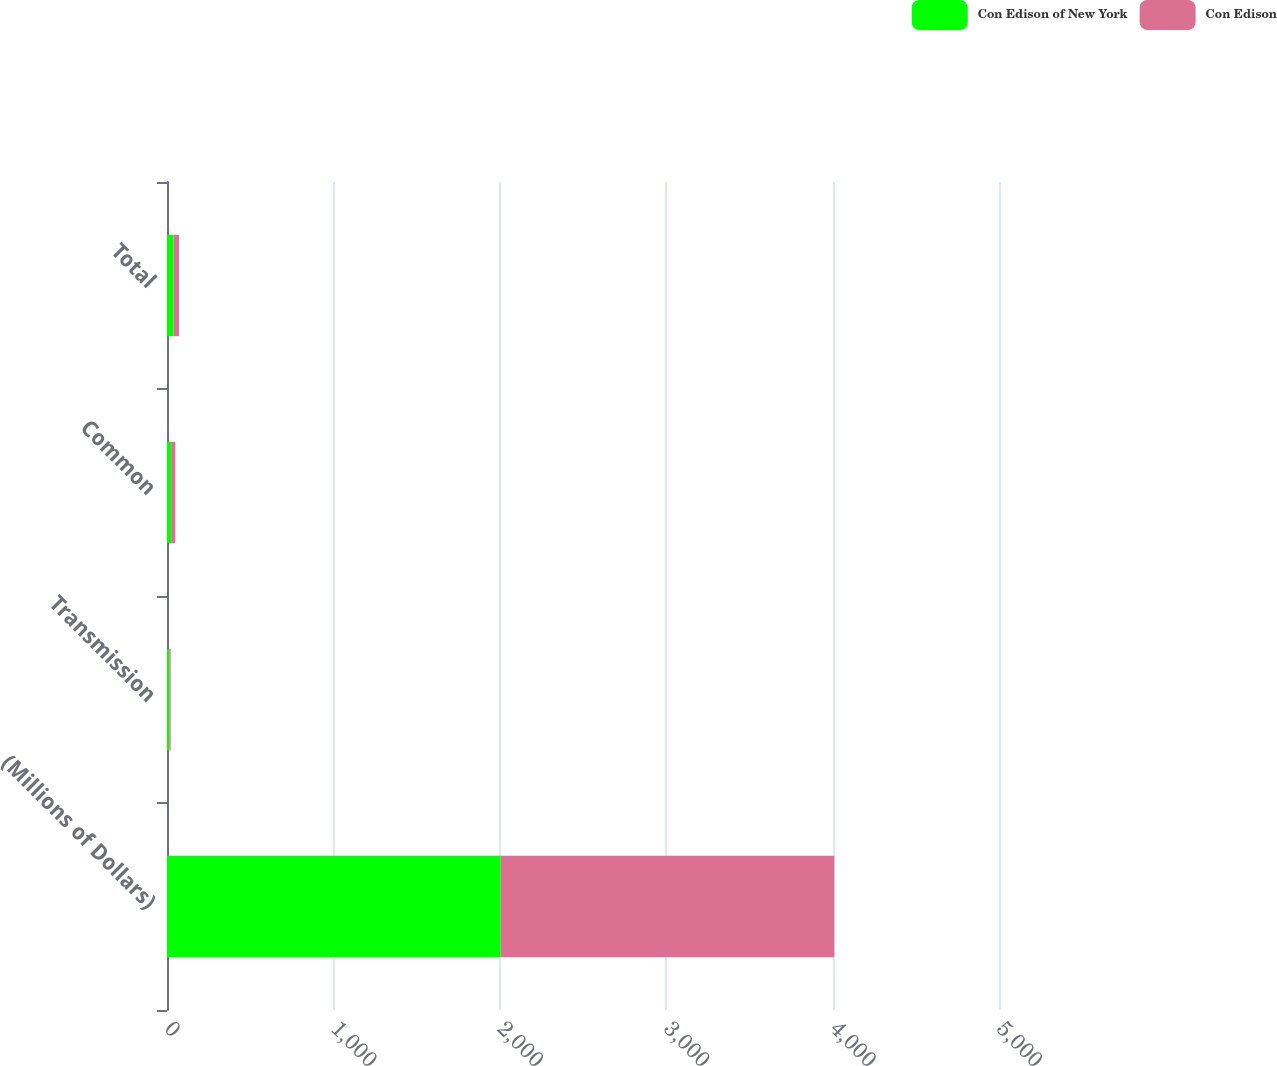Convert chart to OTSL. <chart><loc_0><loc_0><loc_500><loc_500><stacked_bar_chart><ecel><fcel>(Millions of Dollars)<fcel>Transmission<fcel>Common<fcel>Total<nl><fcel>Con Edison of New York<fcel>2005<fcel>14<fcel>25<fcel>39<nl><fcel>Con Edison<fcel>2005<fcel>8<fcel>25<fcel>33<nl></chart> 